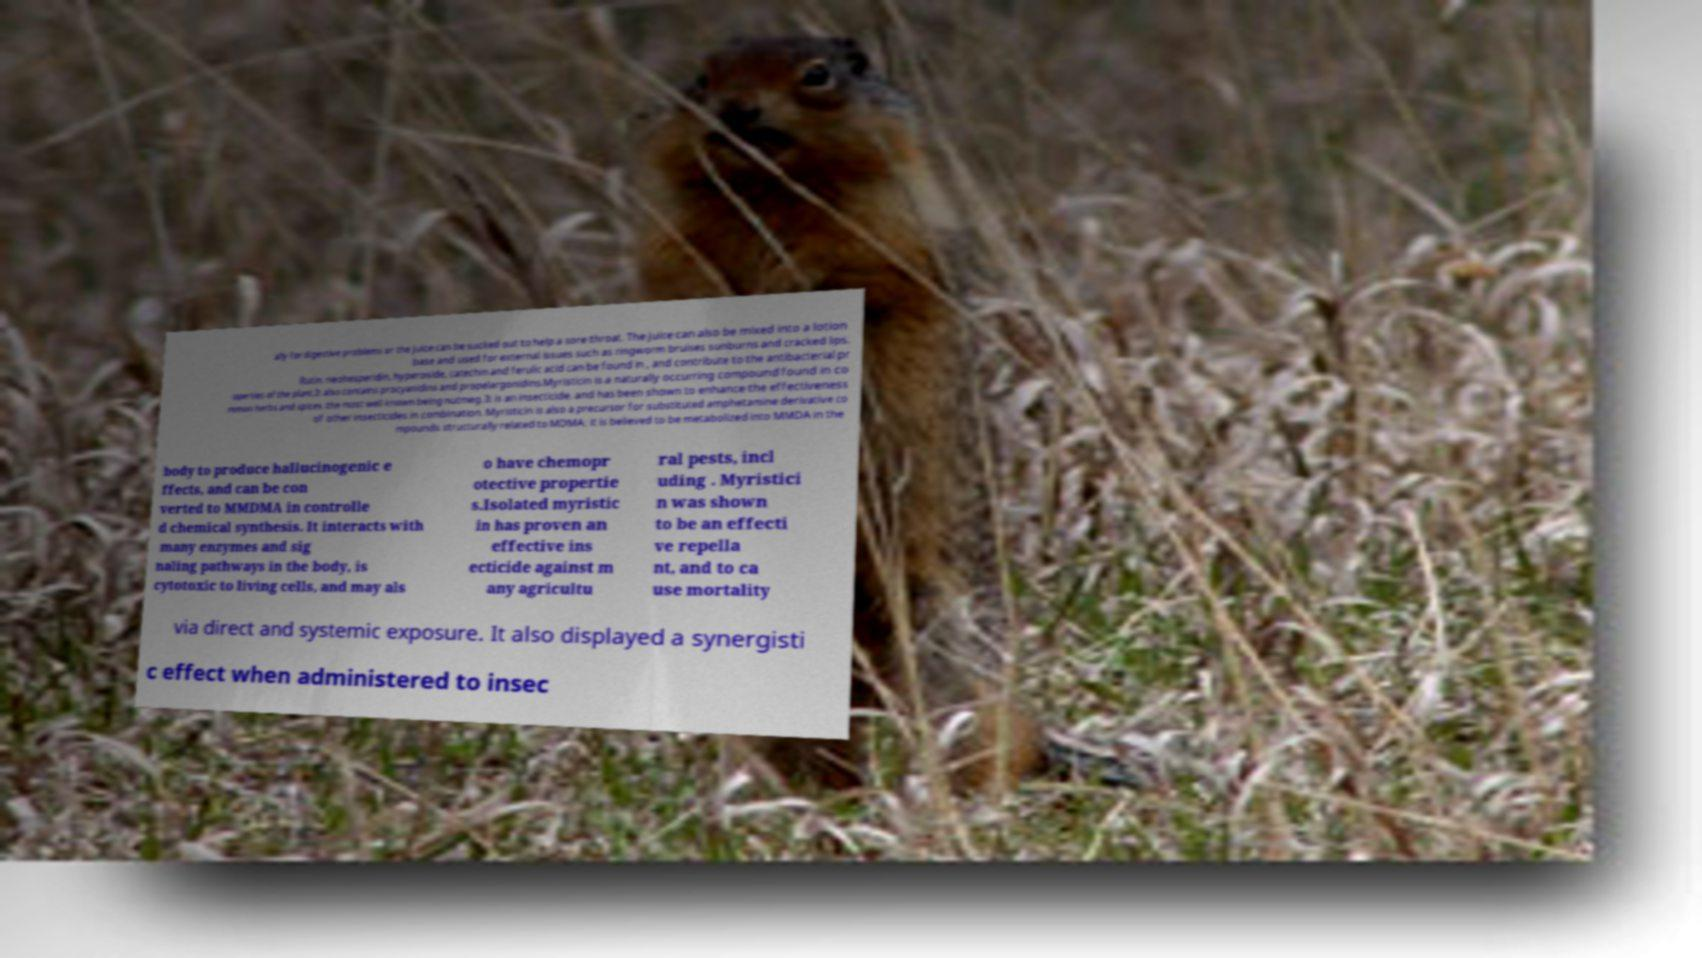What messages or text are displayed in this image? I need them in a readable, typed format. ally for digestive problems or the juice can be sucked out to help a sore throat. The juice can also be mixed into a lotion base and used for external issues such as ringworm bruises sunburns and cracked lips. Rutin, neohesperidin, hyperoside, catechin and ferulic acid can be found in , and contribute to the antibacterial pr operties of the plant.It also contains procyanidins and propelargonidins.Myristicin is a naturally occurring compound found in co mmon herbs and spices, the most well known being nutmeg. It is an insecticide, and has been shown to enhance the effectiveness of other insecticides in combination. Myristicin is also a precursor for substituted amphetamine derivative co mpounds structurally related to MDMA; it is believed to be metabolized into MMDA in the body to produce hallucinogenic e ffects, and can be con verted to MMDMA in controlle d chemical synthesis. It interacts with many enzymes and sig naling pathways in the body, is cytotoxic to living cells, and may als o have chemopr otective propertie s.Isolated myristic in has proven an effective ins ecticide against m any agricultu ral pests, incl uding . Myristici n was shown to be an effecti ve repella nt, and to ca use mortality via direct and systemic exposure. It also displayed a synergisti c effect when administered to insec 